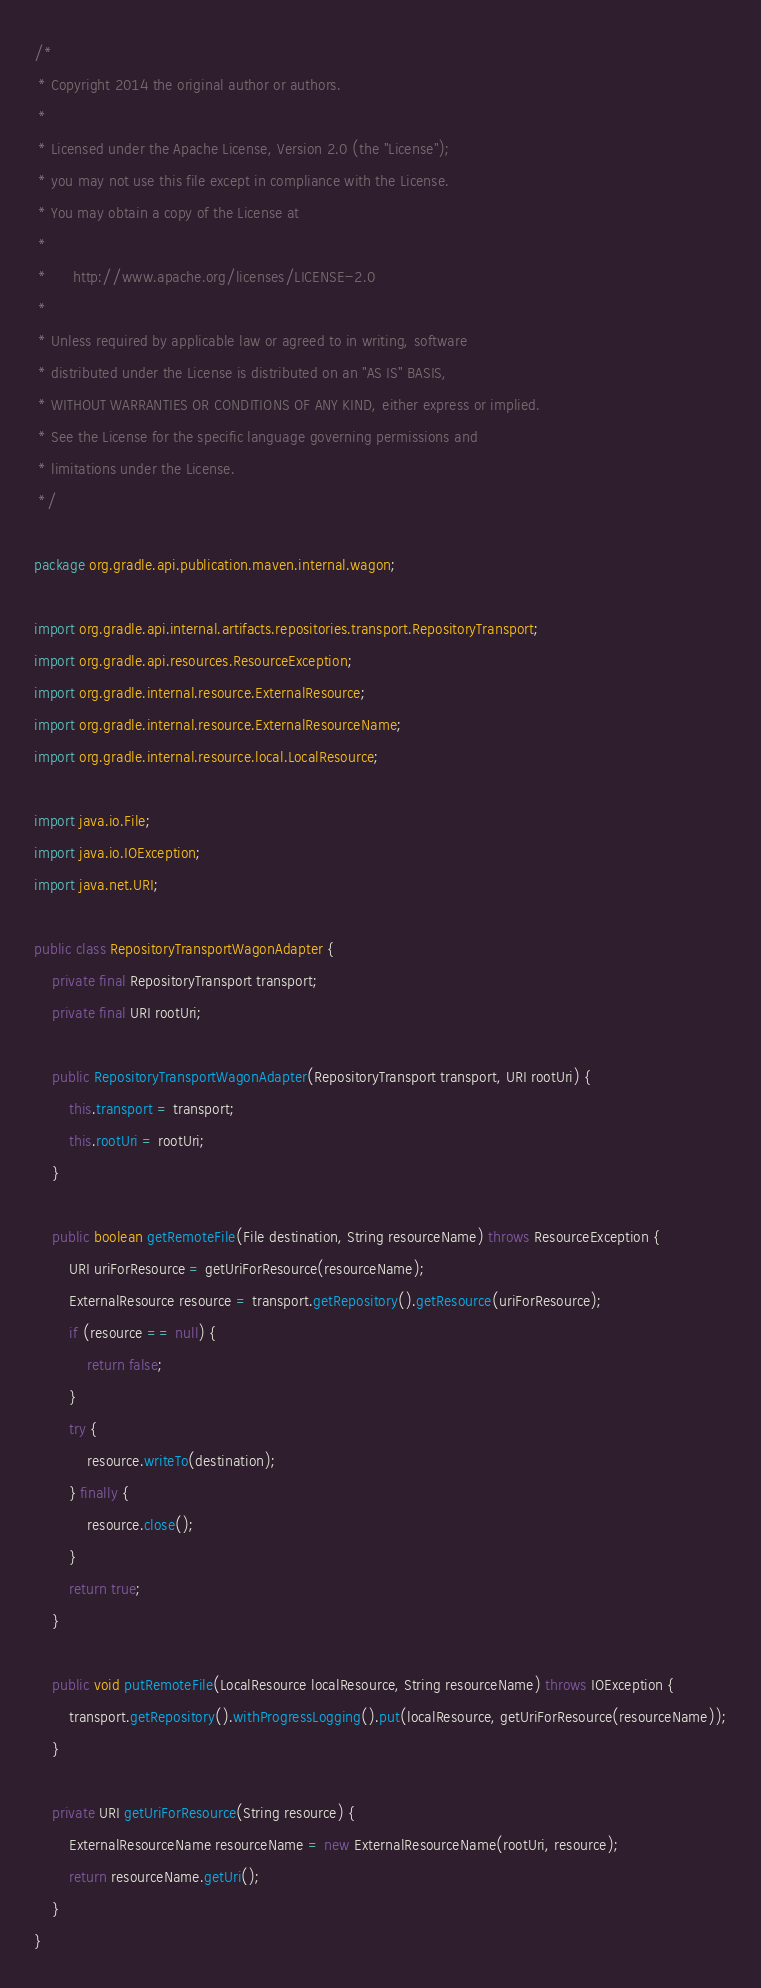Convert code to text. <code><loc_0><loc_0><loc_500><loc_500><_Java_>/*
 * Copyright 2014 the original author or authors.
 *
 * Licensed under the Apache License, Version 2.0 (the "License");
 * you may not use this file except in compliance with the License.
 * You may obtain a copy of the License at
 *
 *      http://www.apache.org/licenses/LICENSE-2.0
 *
 * Unless required by applicable law or agreed to in writing, software
 * distributed under the License is distributed on an "AS IS" BASIS,
 * WITHOUT WARRANTIES OR CONDITIONS OF ANY KIND, either express or implied.
 * See the License for the specific language governing permissions and
 * limitations under the License.
 */

package org.gradle.api.publication.maven.internal.wagon;

import org.gradle.api.internal.artifacts.repositories.transport.RepositoryTransport;
import org.gradle.api.resources.ResourceException;
import org.gradle.internal.resource.ExternalResource;
import org.gradle.internal.resource.ExternalResourceName;
import org.gradle.internal.resource.local.LocalResource;

import java.io.File;
import java.io.IOException;
import java.net.URI;

public class RepositoryTransportWagonAdapter {
    private final RepositoryTransport transport;
    private final URI rootUri;

    public RepositoryTransportWagonAdapter(RepositoryTransport transport, URI rootUri) {
        this.transport = transport;
        this.rootUri = rootUri;
    }

    public boolean getRemoteFile(File destination, String resourceName) throws ResourceException {
        URI uriForResource = getUriForResource(resourceName);
        ExternalResource resource = transport.getRepository().getResource(uriForResource);
        if (resource == null) {
            return false;
        }
        try {
            resource.writeTo(destination);
        } finally {
            resource.close();
        }
        return true;
    }

    public void putRemoteFile(LocalResource localResource, String resourceName) throws IOException {
        transport.getRepository().withProgressLogging().put(localResource, getUriForResource(resourceName));
    }

    private URI getUriForResource(String resource) {
        ExternalResourceName resourceName = new ExternalResourceName(rootUri, resource);
        return resourceName.getUri();
    }
}
</code> 